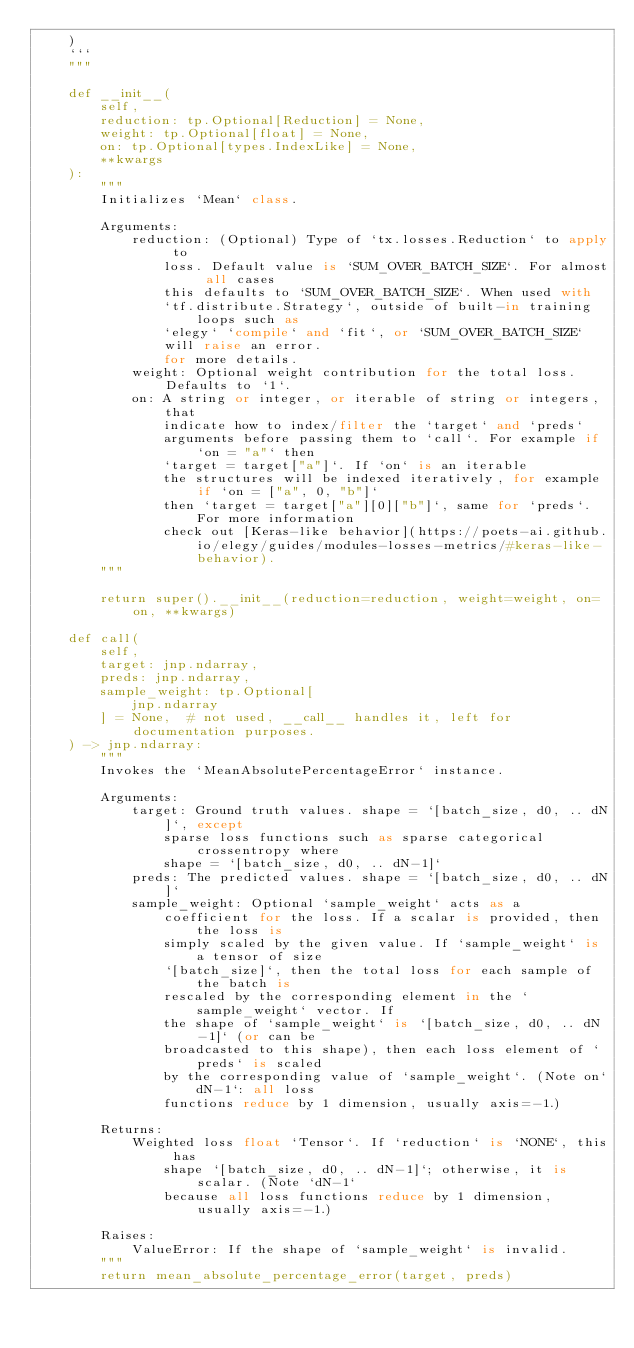<code> <loc_0><loc_0><loc_500><loc_500><_Python_>    )
    ```
    """

    def __init__(
        self,
        reduction: tp.Optional[Reduction] = None,
        weight: tp.Optional[float] = None,
        on: tp.Optional[types.IndexLike] = None,
        **kwargs
    ):
        """
        Initializes `Mean` class.

        Arguments:
            reduction: (Optional) Type of `tx.losses.Reduction` to apply to
                loss. Default value is `SUM_OVER_BATCH_SIZE`. For almost all cases
                this defaults to `SUM_OVER_BATCH_SIZE`. When used with
                `tf.distribute.Strategy`, outside of built-in training loops such as
                `elegy` `compile` and `fit`, or `SUM_OVER_BATCH_SIZE`
                will raise an error.
                for more details.
            weight: Optional weight contribution for the total loss. Defaults to `1`.
            on: A string or integer, or iterable of string or integers, that
                indicate how to index/filter the `target` and `preds`
                arguments before passing them to `call`. For example if `on = "a"` then
                `target = target["a"]`. If `on` is an iterable
                the structures will be indexed iteratively, for example if `on = ["a", 0, "b"]`
                then `target = target["a"][0]["b"]`, same for `preds`. For more information
                check out [Keras-like behavior](https://poets-ai.github.io/elegy/guides/modules-losses-metrics/#keras-like-behavior).
        """

        return super().__init__(reduction=reduction, weight=weight, on=on, **kwargs)

    def call(
        self,
        target: jnp.ndarray,
        preds: jnp.ndarray,
        sample_weight: tp.Optional[
            jnp.ndarray
        ] = None,  # not used, __call__ handles it, left for documentation purposes.
    ) -> jnp.ndarray:
        """
        Invokes the `MeanAbsolutePercentageError` instance.

        Arguments:
            target: Ground truth values. shape = `[batch_size, d0, .. dN]`, except
                sparse loss functions such as sparse categorical crossentropy where
                shape = `[batch_size, d0, .. dN-1]`
            preds: The predicted values. shape = `[batch_size, d0, .. dN]`
            sample_weight: Optional `sample_weight` acts as a
                coefficient for the loss. If a scalar is provided, then the loss is
                simply scaled by the given value. If `sample_weight` is a tensor of size
                `[batch_size]`, then the total loss for each sample of the batch is
                rescaled by the corresponding element in the `sample_weight` vector. If
                the shape of `sample_weight` is `[batch_size, d0, .. dN-1]` (or can be
                broadcasted to this shape), then each loss element of `preds` is scaled
                by the corresponding value of `sample_weight`. (Note on`dN-1`: all loss
                functions reduce by 1 dimension, usually axis=-1.)

        Returns:
            Weighted loss float `Tensor`. If `reduction` is `NONE`, this has
                shape `[batch_size, d0, .. dN-1]`; otherwise, it is scalar. (Note `dN-1`
                because all loss functions reduce by 1 dimension, usually axis=-1.)

        Raises:
            ValueError: If the shape of `sample_weight` is invalid.
        """
        return mean_absolute_percentage_error(target, preds)
</code> 